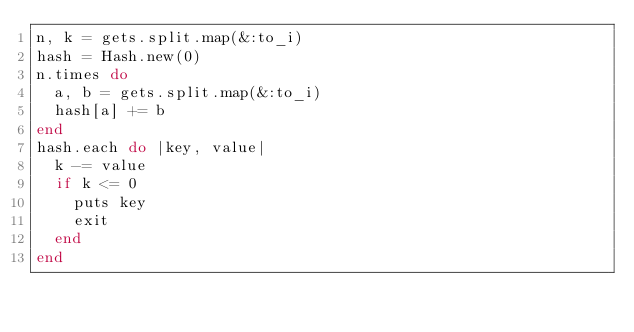Convert code to text. <code><loc_0><loc_0><loc_500><loc_500><_Ruby_>n, k = gets.split.map(&:to_i)
hash = Hash.new(0)
n.times do
  a, b = gets.split.map(&:to_i)
  hash[a] += b
end
hash.each do |key, value|
  k -= value
  if k <= 0
    puts key
    exit
  end
end
</code> 